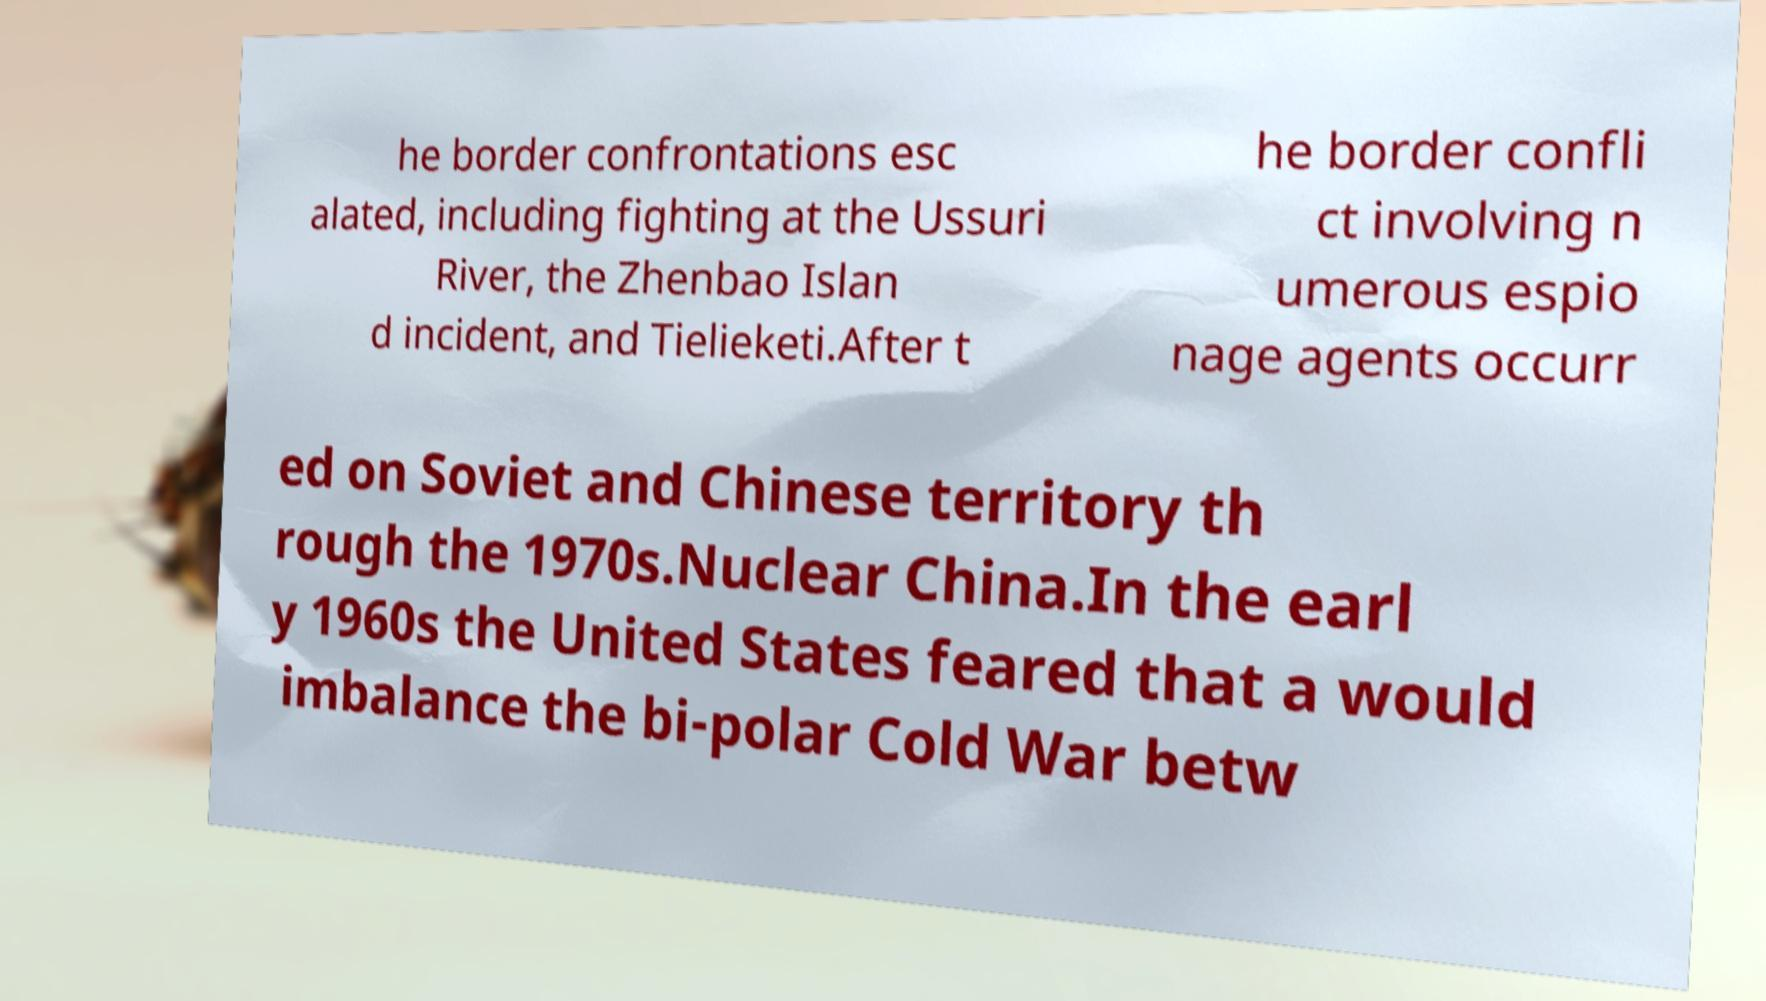Can you accurately transcribe the text from the provided image for me? he border confrontations esc alated, including fighting at the Ussuri River, the Zhenbao Islan d incident, and Tielieketi.After t he border confli ct involving n umerous espio nage agents occurr ed on Soviet and Chinese territory th rough the 1970s.Nuclear China.In the earl y 1960s the United States feared that a would imbalance the bi-polar Cold War betw 